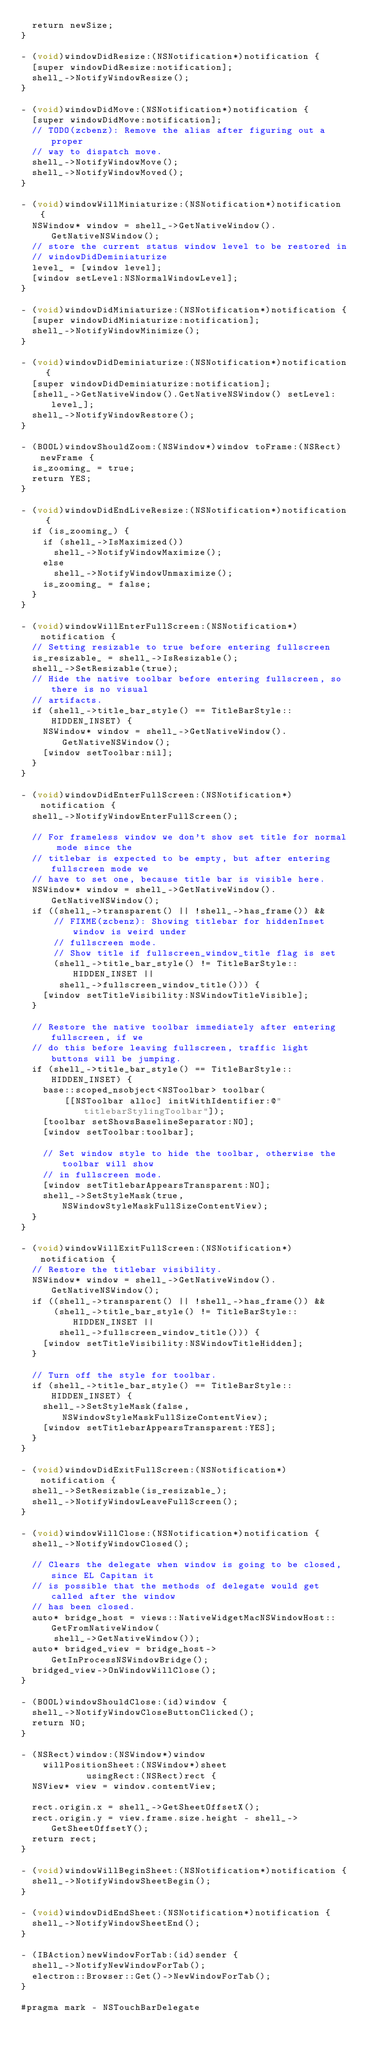<code> <loc_0><loc_0><loc_500><loc_500><_ObjectiveC_>  return newSize;
}

- (void)windowDidResize:(NSNotification*)notification {
  [super windowDidResize:notification];
  shell_->NotifyWindowResize();
}

- (void)windowDidMove:(NSNotification*)notification {
  [super windowDidMove:notification];
  // TODO(zcbenz): Remove the alias after figuring out a proper
  // way to dispatch move.
  shell_->NotifyWindowMove();
  shell_->NotifyWindowMoved();
}

- (void)windowWillMiniaturize:(NSNotification*)notification {
  NSWindow* window = shell_->GetNativeWindow().GetNativeNSWindow();
  // store the current status window level to be restored in
  // windowDidDeminiaturize
  level_ = [window level];
  [window setLevel:NSNormalWindowLevel];
}

- (void)windowDidMiniaturize:(NSNotification*)notification {
  [super windowDidMiniaturize:notification];
  shell_->NotifyWindowMinimize();
}

- (void)windowDidDeminiaturize:(NSNotification*)notification {
  [super windowDidDeminiaturize:notification];
  [shell_->GetNativeWindow().GetNativeNSWindow() setLevel:level_];
  shell_->NotifyWindowRestore();
}

- (BOOL)windowShouldZoom:(NSWindow*)window toFrame:(NSRect)newFrame {
  is_zooming_ = true;
  return YES;
}

- (void)windowDidEndLiveResize:(NSNotification*)notification {
  if (is_zooming_) {
    if (shell_->IsMaximized())
      shell_->NotifyWindowMaximize();
    else
      shell_->NotifyWindowUnmaximize();
    is_zooming_ = false;
  }
}

- (void)windowWillEnterFullScreen:(NSNotification*)notification {
  // Setting resizable to true before entering fullscreen
  is_resizable_ = shell_->IsResizable();
  shell_->SetResizable(true);
  // Hide the native toolbar before entering fullscreen, so there is no visual
  // artifacts.
  if (shell_->title_bar_style() == TitleBarStyle::HIDDEN_INSET) {
    NSWindow* window = shell_->GetNativeWindow().GetNativeNSWindow();
    [window setToolbar:nil];
  }
}

- (void)windowDidEnterFullScreen:(NSNotification*)notification {
  shell_->NotifyWindowEnterFullScreen();

  // For frameless window we don't show set title for normal mode since the
  // titlebar is expected to be empty, but after entering fullscreen mode we
  // have to set one, because title bar is visible here.
  NSWindow* window = shell_->GetNativeWindow().GetNativeNSWindow();
  if ((shell_->transparent() || !shell_->has_frame()) &&
      // FIXME(zcbenz): Showing titlebar for hiddenInset window is weird under
      // fullscreen mode.
      // Show title if fullscreen_window_title flag is set
      (shell_->title_bar_style() != TitleBarStyle::HIDDEN_INSET ||
       shell_->fullscreen_window_title())) {
    [window setTitleVisibility:NSWindowTitleVisible];
  }

  // Restore the native toolbar immediately after entering fullscreen, if we
  // do this before leaving fullscreen, traffic light buttons will be jumping.
  if (shell_->title_bar_style() == TitleBarStyle::HIDDEN_INSET) {
    base::scoped_nsobject<NSToolbar> toolbar(
        [[NSToolbar alloc] initWithIdentifier:@"titlebarStylingToolbar"]);
    [toolbar setShowsBaselineSeparator:NO];
    [window setToolbar:toolbar];

    // Set window style to hide the toolbar, otherwise the toolbar will show
    // in fullscreen mode.
    [window setTitlebarAppearsTransparent:NO];
    shell_->SetStyleMask(true, NSWindowStyleMaskFullSizeContentView);
  }
}

- (void)windowWillExitFullScreen:(NSNotification*)notification {
  // Restore the titlebar visibility.
  NSWindow* window = shell_->GetNativeWindow().GetNativeNSWindow();
  if ((shell_->transparent() || !shell_->has_frame()) &&
      (shell_->title_bar_style() != TitleBarStyle::HIDDEN_INSET ||
       shell_->fullscreen_window_title())) {
    [window setTitleVisibility:NSWindowTitleHidden];
  }

  // Turn off the style for toolbar.
  if (shell_->title_bar_style() == TitleBarStyle::HIDDEN_INSET) {
    shell_->SetStyleMask(false, NSWindowStyleMaskFullSizeContentView);
    [window setTitlebarAppearsTransparent:YES];
  }
}

- (void)windowDidExitFullScreen:(NSNotification*)notification {
  shell_->SetResizable(is_resizable_);
  shell_->NotifyWindowLeaveFullScreen();
}

- (void)windowWillClose:(NSNotification*)notification {
  shell_->NotifyWindowClosed();

  // Clears the delegate when window is going to be closed, since EL Capitan it
  // is possible that the methods of delegate would get called after the window
  // has been closed.
  auto* bridge_host = views::NativeWidgetMacNSWindowHost::GetFromNativeWindow(
      shell_->GetNativeWindow());
  auto* bridged_view = bridge_host->GetInProcessNSWindowBridge();
  bridged_view->OnWindowWillClose();
}

- (BOOL)windowShouldClose:(id)window {
  shell_->NotifyWindowCloseButtonClicked();
  return NO;
}

- (NSRect)window:(NSWindow*)window
    willPositionSheet:(NSWindow*)sheet
            usingRect:(NSRect)rect {
  NSView* view = window.contentView;

  rect.origin.x = shell_->GetSheetOffsetX();
  rect.origin.y = view.frame.size.height - shell_->GetSheetOffsetY();
  return rect;
}

- (void)windowWillBeginSheet:(NSNotification*)notification {
  shell_->NotifyWindowSheetBegin();
}

- (void)windowDidEndSheet:(NSNotification*)notification {
  shell_->NotifyWindowSheetEnd();
}

- (IBAction)newWindowForTab:(id)sender {
  shell_->NotifyNewWindowForTab();
  electron::Browser::Get()->NewWindowForTab();
}

#pragma mark - NSTouchBarDelegate
</code> 